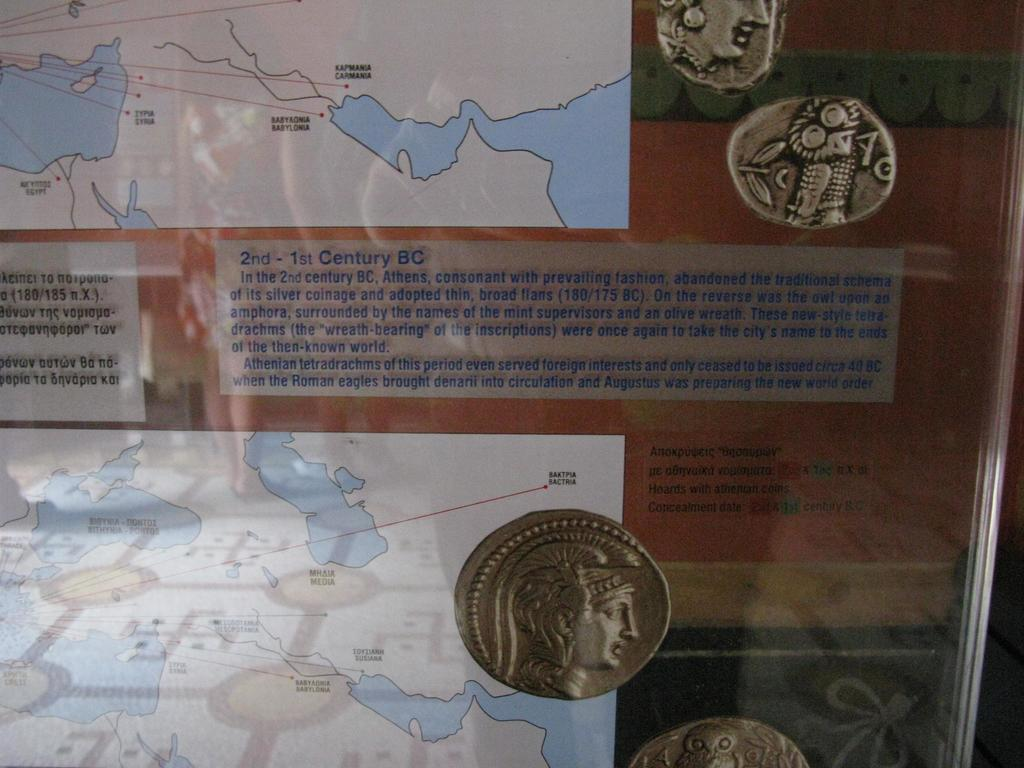<image>
Describe the image concisely. A FEW COINS THAT WERE USED IN 2ND-1ST BC 